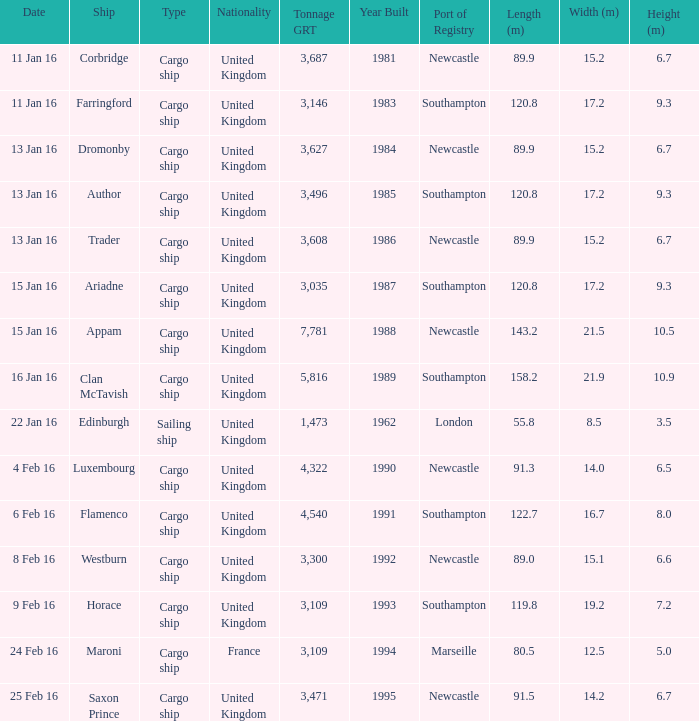What is the nationality of the ship appam? United Kingdom. 